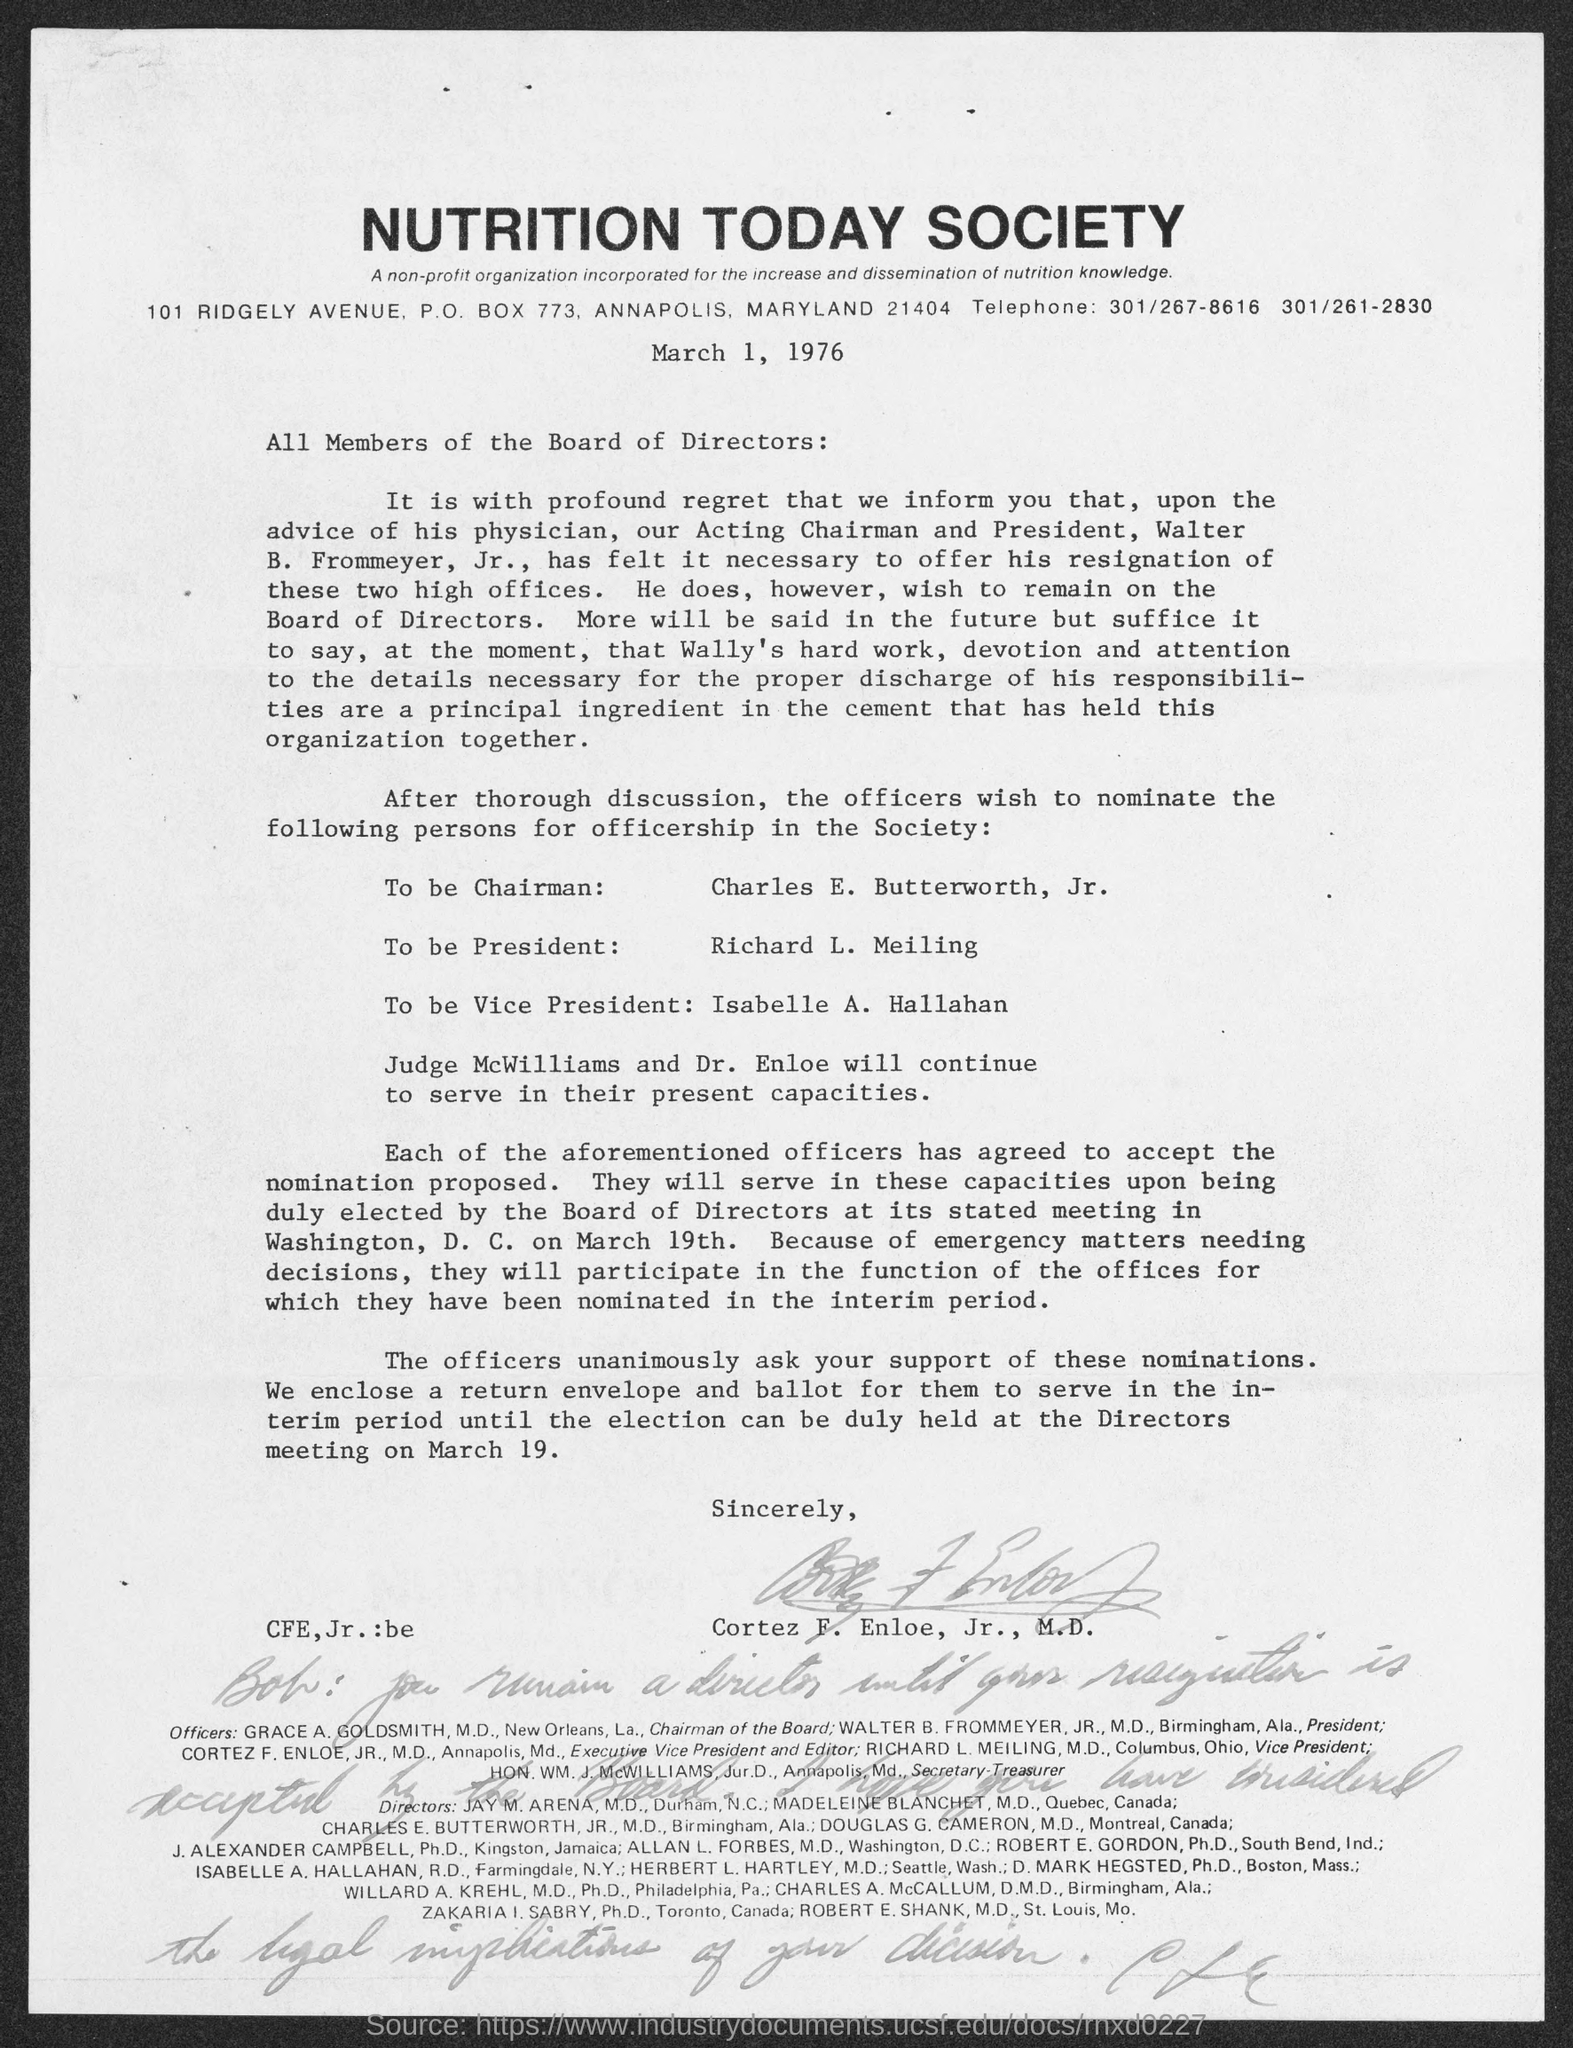Who is to be nominated to be chairman ?
Your answer should be compact. Charles E. Butterworth, Jr. Who is to be nominated as president ?
Give a very brief answer. Richard L. Meiling. Who is to be nominated as vice- president ?
Your answer should be very brief. Isabelle A. Hallahan. 